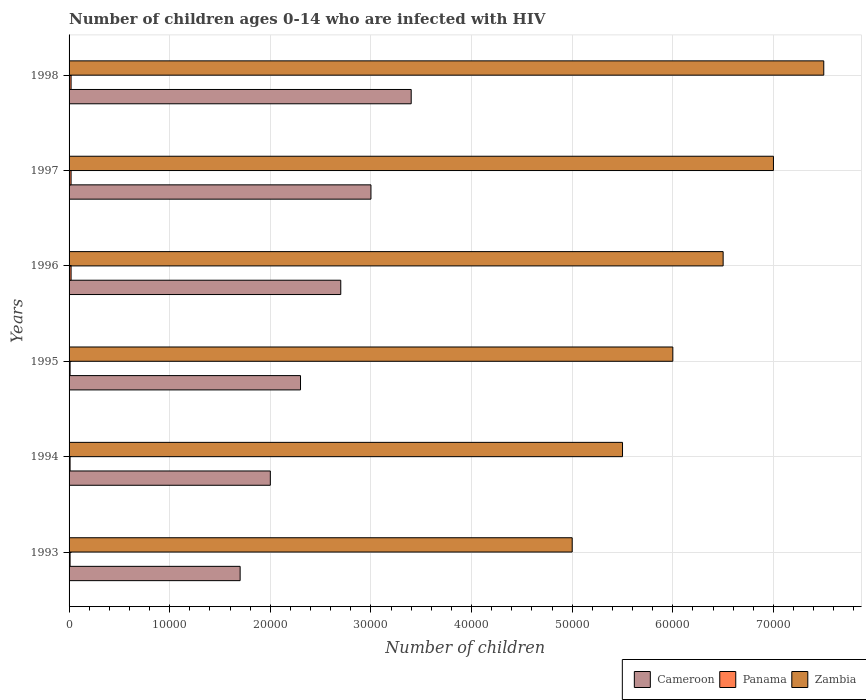How many different coloured bars are there?
Ensure brevity in your answer.  3. How many groups of bars are there?
Keep it short and to the point. 6. Are the number of bars on each tick of the Y-axis equal?
Keep it short and to the point. Yes. How many bars are there on the 3rd tick from the bottom?
Keep it short and to the point. 3. What is the label of the 1st group of bars from the top?
Your answer should be very brief. 1998. What is the number of HIV infected children in Zambia in 1997?
Your response must be concise. 7.00e+04. Across all years, what is the maximum number of HIV infected children in Zambia?
Make the answer very short. 7.50e+04. Across all years, what is the minimum number of HIV infected children in Cameroon?
Offer a terse response. 1.70e+04. In which year was the number of HIV infected children in Zambia maximum?
Provide a succinct answer. 1998. In which year was the number of HIV infected children in Panama minimum?
Your answer should be very brief. 1993. What is the total number of HIV infected children in Zambia in the graph?
Give a very brief answer. 3.75e+05. What is the difference between the number of HIV infected children in Panama in 1995 and that in 1996?
Give a very brief answer. -100. What is the difference between the number of HIV infected children in Cameroon in 1998 and the number of HIV infected children in Panama in 1997?
Provide a succinct answer. 3.38e+04. What is the average number of HIV infected children in Panama per year?
Ensure brevity in your answer.  150. In the year 1993, what is the difference between the number of HIV infected children in Panama and number of HIV infected children in Cameroon?
Ensure brevity in your answer.  -1.69e+04. What is the difference between the highest and the lowest number of HIV infected children in Zambia?
Your answer should be compact. 2.50e+04. What does the 1st bar from the top in 1993 represents?
Give a very brief answer. Zambia. What does the 3rd bar from the bottom in 1994 represents?
Your answer should be compact. Zambia. Is it the case that in every year, the sum of the number of HIV infected children in Zambia and number of HIV infected children in Panama is greater than the number of HIV infected children in Cameroon?
Your response must be concise. Yes. How many bars are there?
Provide a short and direct response. 18. How many years are there in the graph?
Your response must be concise. 6. What is the difference between two consecutive major ticks on the X-axis?
Offer a very short reply. 10000. Does the graph contain any zero values?
Your answer should be very brief. No. Does the graph contain grids?
Your answer should be very brief. Yes. How many legend labels are there?
Provide a short and direct response. 3. What is the title of the graph?
Your answer should be very brief. Number of children ages 0-14 who are infected with HIV. What is the label or title of the X-axis?
Offer a terse response. Number of children. What is the Number of children in Cameroon in 1993?
Offer a very short reply. 1.70e+04. What is the Number of children in Panama in 1993?
Ensure brevity in your answer.  100. What is the Number of children in Zambia in 1993?
Provide a succinct answer. 5.00e+04. What is the Number of children in Cameroon in 1994?
Ensure brevity in your answer.  2.00e+04. What is the Number of children of Panama in 1994?
Ensure brevity in your answer.  100. What is the Number of children in Zambia in 1994?
Your answer should be compact. 5.50e+04. What is the Number of children in Cameroon in 1995?
Your response must be concise. 2.30e+04. What is the Number of children of Panama in 1995?
Give a very brief answer. 100. What is the Number of children in Cameroon in 1996?
Offer a terse response. 2.70e+04. What is the Number of children in Panama in 1996?
Your response must be concise. 200. What is the Number of children of Zambia in 1996?
Your response must be concise. 6.50e+04. What is the Number of children of Panama in 1997?
Your answer should be very brief. 200. What is the Number of children in Zambia in 1997?
Your answer should be very brief. 7.00e+04. What is the Number of children of Cameroon in 1998?
Keep it short and to the point. 3.40e+04. What is the Number of children in Zambia in 1998?
Your response must be concise. 7.50e+04. Across all years, what is the maximum Number of children of Cameroon?
Provide a succinct answer. 3.40e+04. Across all years, what is the maximum Number of children of Zambia?
Give a very brief answer. 7.50e+04. Across all years, what is the minimum Number of children in Cameroon?
Keep it short and to the point. 1.70e+04. Across all years, what is the minimum Number of children in Panama?
Ensure brevity in your answer.  100. What is the total Number of children of Cameroon in the graph?
Offer a very short reply. 1.51e+05. What is the total Number of children of Panama in the graph?
Give a very brief answer. 900. What is the total Number of children in Zambia in the graph?
Provide a short and direct response. 3.75e+05. What is the difference between the Number of children in Cameroon in 1993 and that in 1994?
Your answer should be compact. -3000. What is the difference between the Number of children in Panama in 1993 and that in 1994?
Offer a very short reply. 0. What is the difference between the Number of children of Zambia in 1993 and that in 1994?
Your answer should be compact. -5000. What is the difference between the Number of children in Cameroon in 1993 and that in 1995?
Offer a terse response. -6000. What is the difference between the Number of children in Panama in 1993 and that in 1996?
Offer a very short reply. -100. What is the difference between the Number of children of Zambia in 1993 and that in 1996?
Offer a terse response. -1.50e+04. What is the difference between the Number of children in Cameroon in 1993 and that in 1997?
Your response must be concise. -1.30e+04. What is the difference between the Number of children in Panama in 1993 and that in 1997?
Ensure brevity in your answer.  -100. What is the difference between the Number of children of Zambia in 1993 and that in 1997?
Give a very brief answer. -2.00e+04. What is the difference between the Number of children in Cameroon in 1993 and that in 1998?
Your answer should be very brief. -1.70e+04. What is the difference between the Number of children of Panama in 1993 and that in 1998?
Your answer should be compact. -100. What is the difference between the Number of children of Zambia in 1993 and that in 1998?
Offer a terse response. -2.50e+04. What is the difference between the Number of children in Cameroon in 1994 and that in 1995?
Ensure brevity in your answer.  -3000. What is the difference between the Number of children in Panama in 1994 and that in 1995?
Offer a terse response. 0. What is the difference between the Number of children in Zambia in 1994 and that in 1995?
Keep it short and to the point. -5000. What is the difference between the Number of children in Cameroon in 1994 and that in 1996?
Ensure brevity in your answer.  -7000. What is the difference between the Number of children of Panama in 1994 and that in 1996?
Provide a succinct answer. -100. What is the difference between the Number of children in Zambia in 1994 and that in 1996?
Your answer should be compact. -10000. What is the difference between the Number of children of Cameroon in 1994 and that in 1997?
Provide a succinct answer. -10000. What is the difference between the Number of children of Panama in 1994 and that in 1997?
Offer a very short reply. -100. What is the difference between the Number of children of Zambia in 1994 and that in 1997?
Make the answer very short. -1.50e+04. What is the difference between the Number of children in Cameroon in 1994 and that in 1998?
Offer a terse response. -1.40e+04. What is the difference between the Number of children of Panama in 1994 and that in 1998?
Give a very brief answer. -100. What is the difference between the Number of children in Zambia in 1994 and that in 1998?
Your response must be concise. -2.00e+04. What is the difference between the Number of children in Cameroon in 1995 and that in 1996?
Ensure brevity in your answer.  -4000. What is the difference between the Number of children in Panama in 1995 and that in 1996?
Provide a short and direct response. -100. What is the difference between the Number of children in Zambia in 1995 and that in 1996?
Your answer should be very brief. -5000. What is the difference between the Number of children in Cameroon in 1995 and that in 1997?
Your response must be concise. -7000. What is the difference between the Number of children of Panama in 1995 and that in 1997?
Your answer should be very brief. -100. What is the difference between the Number of children in Cameroon in 1995 and that in 1998?
Make the answer very short. -1.10e+04. What is the difference between the Number of children in Panama in 1995 and that in 1998?
Ensure brevity in your answer.  -100. What is the difference between the Number of children in Zambia in 1995 and that in 1998?
Your answer should be very brief. -1.50e+04. What is the difference between the Number of children of Cameroon in 1996 and that in 1997?
Your answer should be compact. -3000. What is the difference between the Number of children of Zambia in 1996 and that in 1997?
Your answer should be very brief. -5000. What is the difference between the Number of children in Cameroon in 1996 and that in 1998?
Provide a succinct answer. -7000. What is the difference between the Number of children of Panama in 1996 and that in 1998?
Your answer should be very brief. 0. What is the difference between the Number of children of Zambia in 1996 and that in 1998?
Give a very brief answer. -10000. What is the difference between the Number of children of Cameroon in 1997 and that in 1998?
Your response must be concise. -4000. What is the difference between the Number of children of Panama in 1997 and that in 1998?
Provide a succinct answer. 0. What is the difference between the Number of children in Zambia in 1997 and that in 1998?
Your answer should be very brief. -5000. What is the difference between the Number of children of Cameroon in 1993 and the Number of children of Panama in 1994?
Keep it short and to the point. 1.69e+04. What is the difference between the Number of children in Cameroon in 1993 and the Number of children in Zambia in 1994?
Your answer should be very brief. -3.80e+04. What is the difference between the Number of children of Panama in 1993 and the Number of children of Zambia in 1994?
Offer a terse response. -5.49e+04. What is the difference between the Number of children of Cameroon in 1993 and the Number of children of Panama in 1995?
Make the answer very short. 1.69e+04. What is the difference between the Number of children of Cameroon in 1993 and the Number of children of Zambia in 1995?
Your response must be concise. -4.30e+04. What is the difference between the Number of children of Panama in 1993 and the Number of children of Zambia in 1995?
Your response must be concise. -5.99e+04. What is the difference between the Number of children of Cameroon in 1993 and the Number of children of Panama in 1996?
Offer a terse response. 1.68e+04. What is the difference between the Number of children in Cameroon in 1993 and the Number of children in Zambia in 1996?
Ensure brevity in your answer.  -4.80e+04. What is the difference between the Number of children in Panama in 1993 and the Number of children in Zambia in 1996?
Your answer should be compact. -6.49e+04. What is the difference between the Number of children of Cameroon in 1993 and the Number of children of Panama in 1997?
Your answer should be compact. 1.68e+04. What is the difference between the Number of children of Cameroon in 1993 and the Number of children of Zambia in 1997?
Ensure brevity in your answer.  -5.30e+04. What is the difference between the Number of children in Panama in 1993 and the Number of children in Zambia in 1997?
Your response must be concise. -6.99e+04. What is the difference between the Number of children of Cameroon in 1993 and the Number of children of Panama in 1998?
Offer a terse response. 1.68e+04. What is the difference between the Number of children in Cameroon in 1993 and the Number of children in Zambia in 1998?
Provide a short and direct response. -5.80e+04. What is the difference between the Number of children in Panama in 1993 and the Number of children in Zambia in 1998?
Keep it short and to the point. -7.49e+04. What is the difference between the Number of children in Cameroon in 1994 and the Number of children in Panama in 1995?
Give a very brief answer. 1.99e+04. What is the difference between the Number of children of Cameroon in 1994 and the Number of children of Zambia in 1995?
Your answer should be very brief. -4.00e+04. What is the difference between the Number of children in Panama in 1994 and the Number of children in Zambia in 1995?
Your answer should be very brief. -5.99e+04. What is the difference between the Number of children of Cameroon in 1994 and the Number of children of Panama in 1996?
Make the answer very short. 1.98e+04. What is the difference between the Number of children of Cameroon in 1994 and the Number of children of Zambia in 1996?
Your response must be concise. -4.50e+04. What is the difference between the Number of children in Panama in 1994 and the Number of children in Zambia in 1996?
Offer a very short reply. -6.49e+04. What is the difference between the Number of children of Cameroon in 1994 and the Number of children of Panama in 1997?
Offer a very short reply. 1.98e+04. What is the difference between the Number of children of Panama in 1994 and the Number of children of Zambia in 1997?
Offer a very short reply. -6.99e+04. What is the difference between the Number of children of Cameroon in 1994 and the Number of children of Panama in 1998?
Your answer should be very brief. 1.98e+04. What is the difference between the Number of children in Cameroon in 1994 and the Number of children in Zambia in 1998?
Your answer should be compact. -5.50e+04. What is the difference between the Number of children in Panama in 1994 and the Number of children in Zambia in 1998?
Ensure brevity in your answer.  -7.49e+04. What is the difference between the Number of children in Cameroon in 1995 and the Number of children in Panama in 1996?
Your answer should be very brief. 2.28e+04. What is the difference between the Number of children of Cameroon in 1995 and the Number of children of Zambia in 1996?
Your answer should be compact. -4.20e+04. What is the difference between the Number of children of Panama in 1995 and the Number of children of Zambia in 1996?
Provide a short and direct response. -6.49e+04. What is the difference between the Number of children in Cameroon in 1995 and the Number of children in Panama in 1997?
Offer a terse response. 2.28e+04. What is the difference between the Number of children of Cameroon in 1995 and the Number of children of Zambia in 1997?
Offer a very short reply. -4.70e+04. What is the difference between the Number of children in Panama in 1995 and the Number of children in Zambia in 1997?
Your answer should be very brief. -6.99e+04. What is the difference between the Number of children of Cameroon in 1995 and the Number of children of Panama in 1998?
Provide a succinct answer. 2.28e+04. What is the difference between the Number of children of Cameroon in 1995 and the Number of children of Zambia in 1998?
Give a very brief answer. -5.20e+04. What is the difference between the Number of children in Panama in 1995 and the Number of children in Zambia in 1998?
Provide a short and direct response. -7.49e+04. What is the difference between the Number of children of Cameroon in 1996 and the Number of children of Panama in 1997?
Provide a short and direct response. 2.68e+04. What is the difference between the Number of children in Cameroon in 1996 and the Number of children in Zambia in 1997?
Your answer should be very brief. -4.30e+04. What is the difference between the Number of children of Panama in 1996 and the Number of children of Zambia in 1997?
Give a very brief answer. -6.98e+04. What is the difference between the Number of children in Cameroon in 1996 and the Number of children in Panama in 1998?
Offer a very short reply. 2.68e+04. What is the difference between the Number of children in Cameroon in 1996 and the Number of children in Zambia in 1998?
Offer a very short reply. -4.80e+04. What is the difference between the Number of children in Panama in 1996 and the Number of children in Zambia in 1998?
Make the answer very short. -7.48e+04. What is the difference between the Number of children in Cameroon in 1997 and the Number of children in Panama in 1998?
Give a very brief answer. 2.98e+04. What is the difference between the Number of children in Cameroon in 1997 and the Number of children in Zambia in 1998?
Offer a terse response. -4.50e+04. What is the difference between the Number of children in Panama in 1997 and the Number of children in Zambia in 1998?
Your response must be concise. -7.48e+04. What is the average Number of children in Cameroon per year?
Offer a terse response. 2.52e+04. What is the average Number of children in Panama per year?
Give a very brief answer. 150. What is the average Number of children of Zambia per year?
Your answer should be very brief. 6.25e+04. In the year 1993, what is the difference between the Number of children in Cameroon and Number of children in Panama?
Your answer should be compact. 1.69e+04. In the year 1993, what is the difference between the Number of children of Cameroon and Number of children of Zambia?
Your answer should be very brief. -3.30e+04. In the year 1993, what is the difference between the Number of children of Panama and Number of children of Zambia?
Offer a very short reply. -4.99e+04. In the year 1994, what is the difference between the Number of children in Cameroon and Number of children in Panama?
Your answer should be very brief. 1.99e+04. In the year 1994, what is the difference between the Number of children in Cameroon and Number of children in Zambia?
Make the answer very short. -3.50e+04. In the year 1994, what is the difference between the Number of children of Panama and Number of children of Zambia?
Ensure brevity in your answer.  -5.49e+04. In the year 1995, what is the difference between the Number of children in Cameroon and Number of children in Panama?
Offer a terse response. 2.29e+04. In the year 1995, what is the difference between the Number of children of Cameroon and Number of children of Zambia?
Provide a succinct answer. -3.70e+04. In the year 1995, what is the difference between the Number of children of Panama and Number of children of Zambia?
Keep it short and to the point. -5.99e+04. In the year 1996, what is the difference between the Number of children of Cameroon and Number of children of Panama?
Your response must be concise. 2.68e+04. In the year 1996, what is the difference between the Number of children in Cameroon and Number of children in Zambia?
Keep it short and to the point. -3.80e+04. In the year 1996, what is the difference between the Number of children of Panama and Number of children of Zambia?
Give a very brief answer. -6.48e+04. In the year 1997, what is the difference between the Number of children of Cameroon and Number of children of Panama?
Your response must be concise. 2.98e+04. In the year 1997, what is the difference between the Number of children in Panama and Number of children in Zambia?
Your answer should be compact. -6.98e+04. In the year 1998, what is the difference between the Number of children in Cameroon and Number of children in Panama?
Provide a succinct answer. 3.38e+04. In the year 1998, what is the difference between the Number of children of Cameroon and Number of children of Zambia?
Ensure brevity in your answer.  -4.10e+04. In the year 1998, what is the difference between the Number of children of Panama and Number of children of Zambia?
Give a very brief answer. -7.48e+04. What is the ratio of the Number of children of Cameroon in 1993 to that in 1994?
Provide a succinct answer. 0.85. What is the ratio of the Number of children in Zambia in 1993 to that in 1994?
Make the answer very short. 0.91. What is the ratio of the Number of children in Cameroon in 1993 to that in 1995?
Your answer should be very brief. 0.74. What is the ratio of the Number of children in Zambia in 1993 to that in 1995?
Provide a short and direct response. 0.83. What is the ratio of the Number of children of Cameroon in 1993 to that in 1996?
Ensure brevity in your answer.  0.63. What is the ratio of the Number of children in Zambia in 1993 to that in 1996?
Offer a terse response. 0.77. What is the ratio of the Number of children in Cameroon in 1993 to that in 1997?
Keep it short and to the point. 0.57. What is the ratio of the Number of children in Zambia in 1993 to that in 1997?
Provide a short and direct response. 0.71. What is the ratio of the Number of children in Panama in 1993 to that in 1998?
Provide a succinct answer. 0.5. What is the ratio of the Number of children in Cameroon in 1994 to that in 1995?
Make the answer very short. 0.87. What is the ratio of the Number of children in Zambia in 1994 to that in 1995?
Offer a terse response. 0.92. What is the ratio of the Number of children in Cameroon in 1994 to that in 1996?
Your answer should be compact. 0.74. What is the ratio of the Number of children of Zambia in 1994 to that in 1996?
Your answer should be very brief. 0.85. What is the ratio of the Number of children of Cameroon in 1994 to that in 1997?
Offer a terse response. 0.67. What is the ratio of the Number of children in Zambia in 1994 to that in 1997?
Make the answer very short. 0.79. What is the ratio of the Number of children in Cameroon in 1994 to that in 1998?
Give a very brief answer. 0.59. What is the ratio of the Number of children of Panama in 1994 to that in 1998?
Give a very brief answer. 0.5. What is the ratio of the Number of children of Zambia in 1994 to that in 1998?
Your response must be concise. 0.73. What is the ratio of the Number of children of Cameroon in 1995 to that in 1996?
Provide a succinct answer. 0.85. What is the ratio of the Number of children of Panama in 1995 to that in 1996?
Provide a short and direct response. 0.5. What is the ratio of the Number of children of Cameroon in 1995 to that in 1997?
Ensure brevity in your answer.  0.77. What is the ratio of the Number of children in Zambia in 1995 to that in 1997?
Offer a very short reply. 0.86. What is the ratio of the Number of children of Cameroon in 1995 to that in 1998?
Keep it short and to the point. 0.68. What is the ratio of the Number of children of Panama in 1995 to that in 1998?
Offer a very short reply. 0.5. What is the ratio of the Number of children in Zambia in 1995 to that in 1998?
Ensure brevity in your answer.  0.8. What is the ratio of the Number of children in Panama in 1996 to that in 1997?
Your response must be concise. 1. What is the ratio of the Number of children in Zambia in 1996 to that in 1997?
Offer a very short reply. 0.93. What is the ratio of the Number of children in Cameroon in 1996 to that in 1998?
Offer a very short reply. 0.79. What is the ratio of the Number of children of Zambia in 1996 to that in 1998?
Your answer should be compact. 0.87. What is the ratio of the Number of children in Cameroon in 1997 to that in 1998?
Your answer should be very brief. 0.88. What is the ratio of the Number of children of Zambia in 1997 to that in 1998?
Offer a terse response. 0.93. What is the difference between the highest and the second highest Number of children in Cameroon?
Your response must be concise. 4000. What is the difference between the highest and the second highest Number of children in Panama?
Keep it short and to the point. 0. What is the difference between the highest and the lowest Number of children in Cameroon?
Provide a short and direct response. 1.70e+04. What is the difference between the highest and the lowest Number of children of Panama?
Give a very brief answer. 100. What is the difference between the highest and the lowest Number of children in Zambia?
Provide a succinct answer. 2.50e+04. 